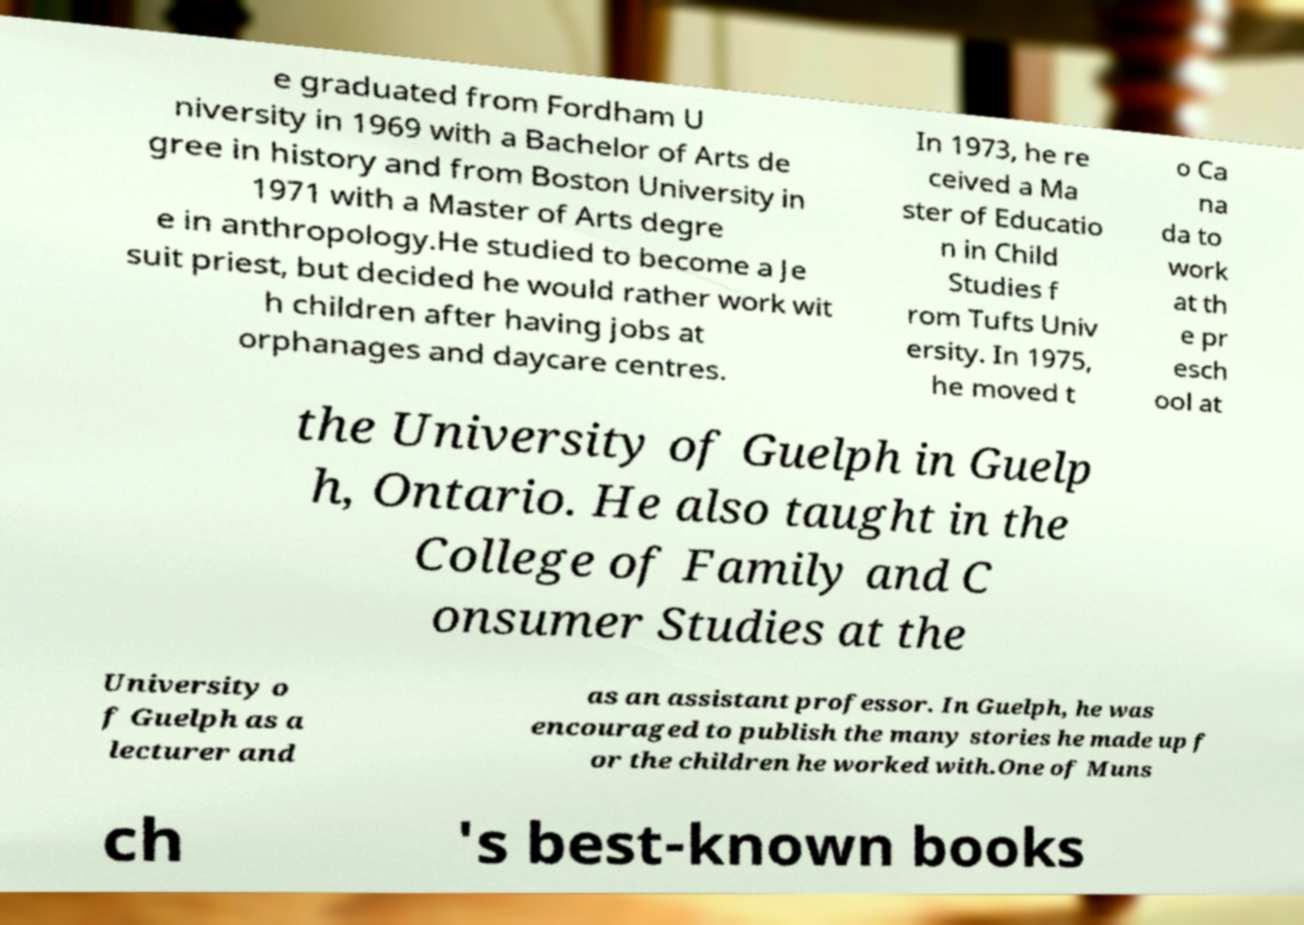What messages or text are displayed in this image? I need them in a readable, typed format. e graduated from Fordham U niversity in 1969 with a Bachelor of Arts de gree in history and from Boston University in 1971 with a Master of Arts degre e in anthropology.He studied to become a Je suit priest, but decided he would rather work wit h children after having jobs at orphanages and daycare centres. In 1973, he re ceived a Ma ster of Educatio n in Child Studies f rom Tufts Univ ersity. In 1975, he moved t o Ca na da to work at th e pr esch ool at the University of Guelph in Guelp h, Ontario. He also taught in the College of Family and C onsumer Studies at the University o f Guelph as a lecturer and as an assistant professor. In Guelph, he was encouraged to publish the many stories he made up f or the children he worked with.One of Muns ch 's best-known books 